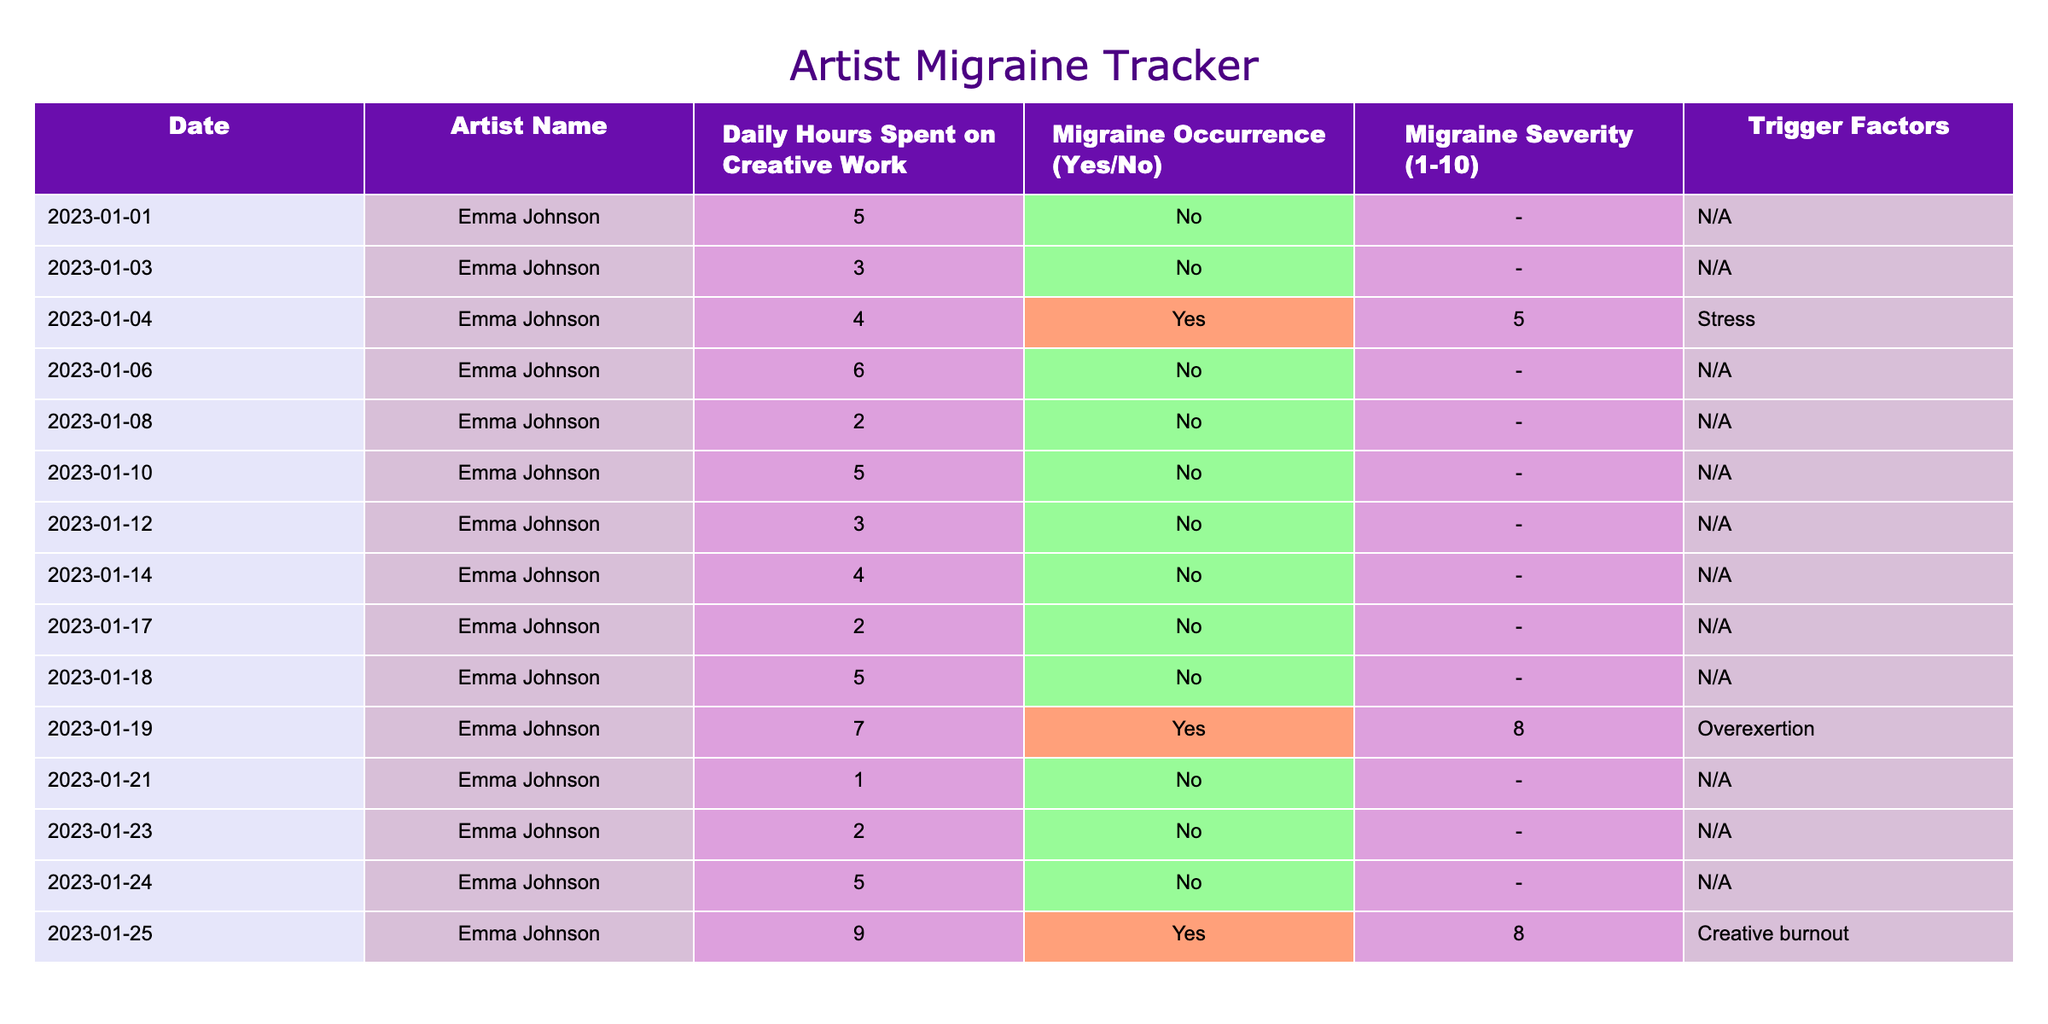How many days did Emma Johnson experience migraines? In the table, I count the rows where 'Migraine Occurrence' is 'Yes'. There are three such days: January 4, January 19, and January 25.
Answer: 3 What is the highest migraine severity recorded for Emma Johnson? Looking at the 'Migraine Severity' column, the highest value is 8, which occurs on January 19 and January 25.
Answer: 8 On how many days did Emma Johnson spend more than 5 hours on creative work? I need to check the 'Daily Hours Spent on Creative Work' column for values greater than 5. The days with more than 5 hours are January 6 (6 hours), January 19 (7 hours), and January 25 (9 hours), totaling 3 days.
Answer: 3 What percentage of the days did Emma experience migraines after spending more than 5 hours on creative work? Emma experienced migraines on January 19 and January 25 when she spent 7 and 9 hours, respectively. There are 3 days with more than 5 hours spent on creative work: January 6, 19, and 25. The percentage is (2/3) * 100 = 66.67%.
Answer: 66.67% Did Emma Johnson ever experience a migraine without exceeding 5 hours of creative work? By reviewing the table, I see that all instances of migraine occurrence correspond to days when creative work hours exceeded 5. Thus, there are no occurrences of migraines below this threshold.
Answer: No What is the average number of hours spent on creative work on days when Emma had a migraine? The days with migraines are January 4 (4 hours), January 19 (7 hours), and January 25 (9 hours) with a total of 20 hours. There are 3 days, so the average is 20/3 = approximately 6.67 hours.
Answer: 6.67 Which trigger factor corresponded to the highest severity of migraine? The highest recorded severity is 8, which has two occurrences, on January 19 and January 25, with trigger factors being "Overexertion" and "Creative burnout," respectively. Therefore, the highest severity corresponds to both factors.
Answer: Overexertion and Creative burnout How many total hours did Emma work on days without experiencing a migraine? By summing the hours from the rows with 'Migraine Occurrence' as 'No': 5 (January 1) + 3 (January 3) + 6 (January 6) + 2 (January 8) + 5 (January 10) + 3 (January 12) + 4 (January 14) + 2 (January 17) + 5 (January 18) = 35 hours in total.
Answer: 35 What is the difference in daily hours spent on creative work between the days with the highest and lowest occurrences? The highest daily hours spent on creative work is 9 (January 25), and the lowest is 1 (January 21). The difference is 9 - 1 = 8 hours.
Answer: 8 